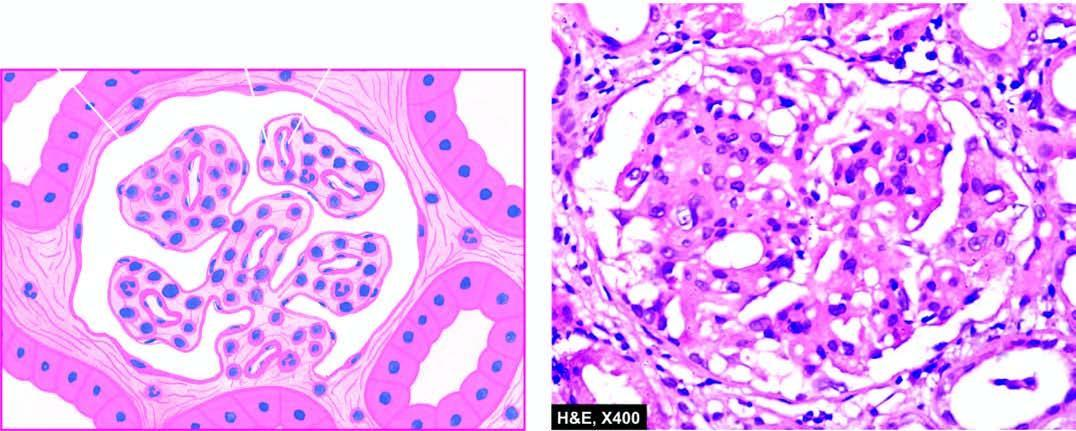s the centre increased in the mesangial matrix between the capillaries?
Answer the question using a single word or phrase. No 